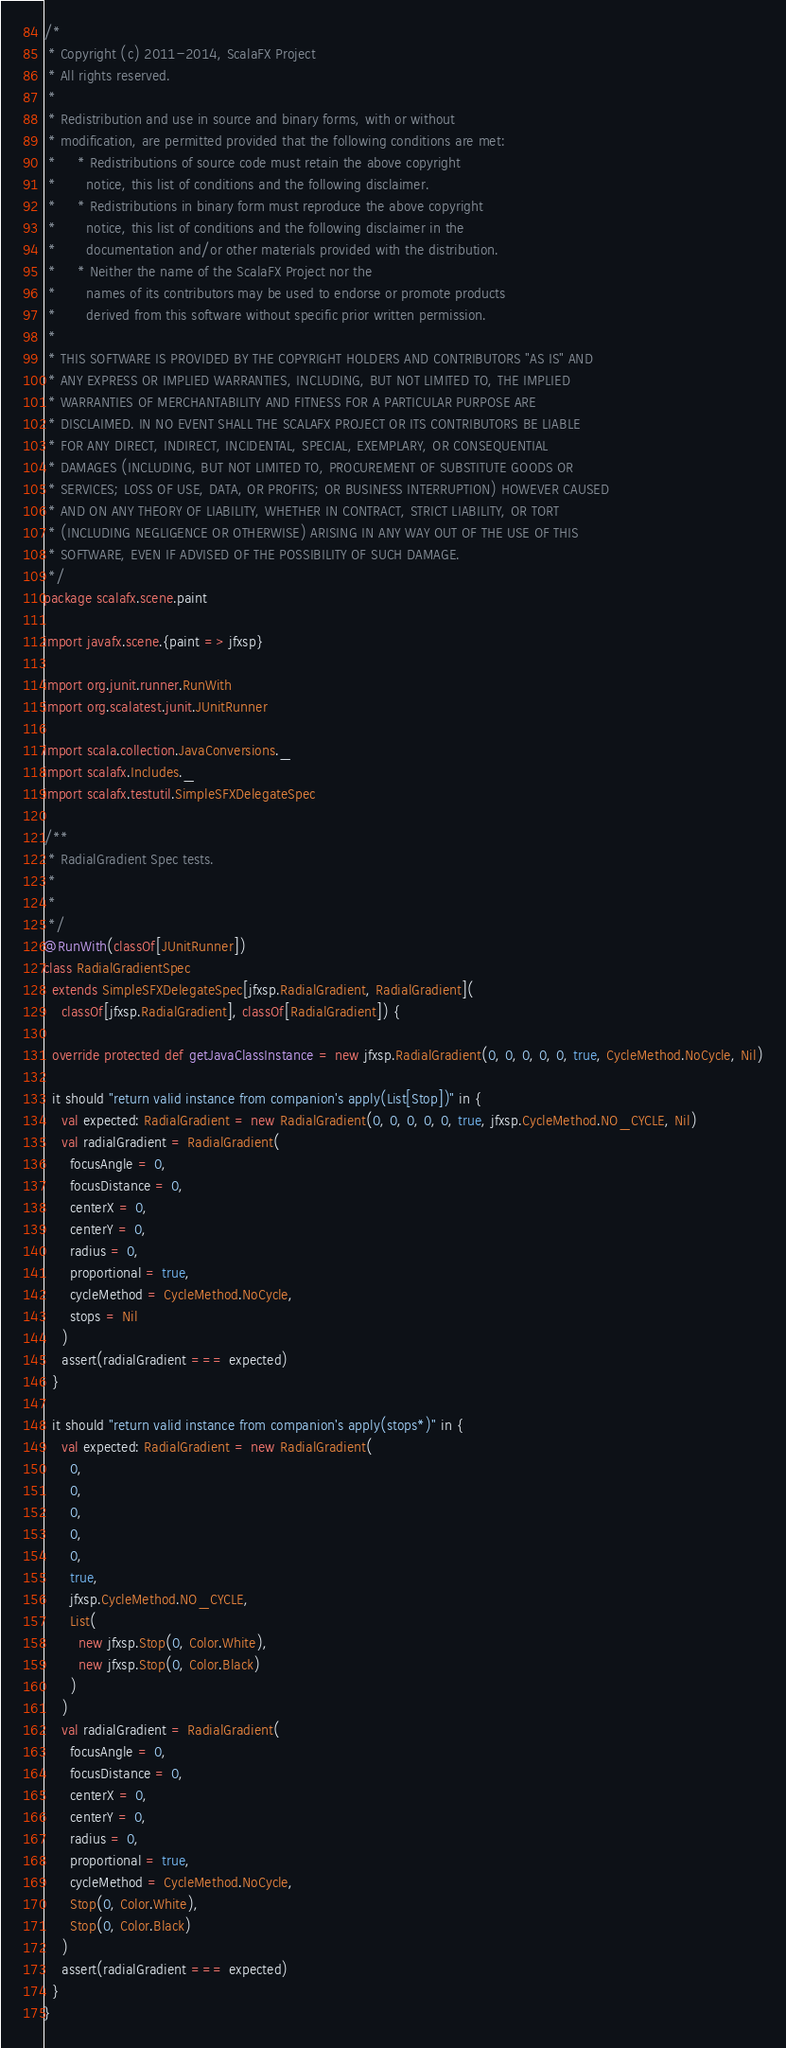<code> <loc_0><loc_0><loc_500><loc_500><_Scala_>/*
 * Copyright (c) 2011-2014, ScalaFX Project
 * All rights reserved.
 *
 * Redistribution and use in source and binary forms, with or without
 * modification, are permitted provided that the following conditions are met:
 *     * Redistributions of source code must retain the above copyright
 *       notice, this list of conditions and the following disclaimer.
 *     * Redistributions in binary form must reproduce the above copyright
 *       notice, this list of conditions and the following disclaimer in the
 *       documentation and/or other materials provided with the distribution.
 *     * Neither the name of the ScalaFX Project nor the
 *       names of its contributors may be used to endorse or promote products
 *       derived from this software without specific prior written permission.
 *
 * THIS SOFTWARE IS PROVIDED BY THE COPYRIGHT HOLDERS AND CONTRIBUTORS "AS IS" AND
 * ANY EXPRESS OR IMPLIED WARRANTIES, INCLUDING, BUT NOT LIMITED TO, THE IMPLIED
 * WARRANTIES OF MERCHANTABILITY AND FITNESS FOR A PARTICULAR PURPOSE ARE
 * DISCLAIMED. IN NO EVENT SHALL THE SCALAFX PROJECT OR ITS CONTRIBUTORS BE LIABLE
 * FOR ANY DIRECT, INDIRECT, INCIDENTAL, SPECIAL, EXEMPLARY, OR CONSEQUENTIAL
 * DAMAGES (INCLUDING, BUT NOT LIMITED TO, PROCUREMENT OF SUBSTITUTE GOODS OR
 * SERVICES; LOSS OF USE, DATA, OR PROFITS; OR BUSINESS INTERRUPTION) HOWEVER CAUSED
 * AND ON ANY THEORY OF LIABILITY, WHETHER IN CONTRACT, STRICT LIABILITY, OR TORT
 * (INCLUDING NEGLIGENCE OR OTHERWISE) ARISING IN ANY WAY OUT OF THE USE OF THIS
 * SOFTWARE, EVEN IF ADVISED OF THE POSSIBILITY OF SUCH DAMAGE.
 */
package scalafx.scene.paint

import javafx.scene.{paint => jfxsp}

import org.junit.runner.RunWith
import org.scalatest.junit.JUnitRunner

import scala.collection.JavaConversions._
import scalafx.Includes._
import scalafx.testutil.SimpleSFXDelegateSpec

/**
 * RadialGradient Spec tests.
 *
 *
 */
@RunWith(classOf[JUnitRunner])
class RadialGradientSpec
  extends SimpleSFXDelegateSpec[jfxsp.RadialGradient, RadialGradient](
    classOf[jfxsp.RadialGradient], classOf[RadialGradient]) {

  override protected def getJavaClassInstance = new jfxsp.RadialGradient(0, 0, 0, 0, 0, true, CycleMethod.NoCycle, Nil)

  it should "return valid instance from companion's apply(List[Stop])" in {
    val expected: RadialGradient = new RadialGradient(0, 0, 0, 0, 0, true, jfxsp.CycleMethod.NO_CYCLE, Nil)
    val radialGradient = RadialGradient(
      focusAngle = 0,
      focusDistance = 0,
      centerX = 0,
      centerY = 0,
      radius = 0,
      proportional = true,
      cycleMethod = CycleMethod.NoCycle,
      stops = Nil
    )
    assert(radialGradient === expected)
  }

  it should "return valid instance from companion's apply(stops*)" in {
    val expected: RadialGradient = new RadialGradient(
      0,
      0,
      0,
      0,
      0,
      true,
      jfxsp.CycleMethod.NO_CYCLE,
      List(
        new jfxsp.Stop(0, Color.White),
        new jfxsp.Stop(0, Color.Black)
      )
    )
    val radialGradient = RadialGradient(
      focusAngle = 0,
      focusDistance = 0,
      centerX = 0,
      centerY = 0,
      radius = 0,
      proportional = true,
      cycleMethod = CycleMethod.NoCycle,
      Stop(0, Color.White),
      Stop(0, Color.Black)
    )
    assert(radialGradient === expected)
  }
}</code> 